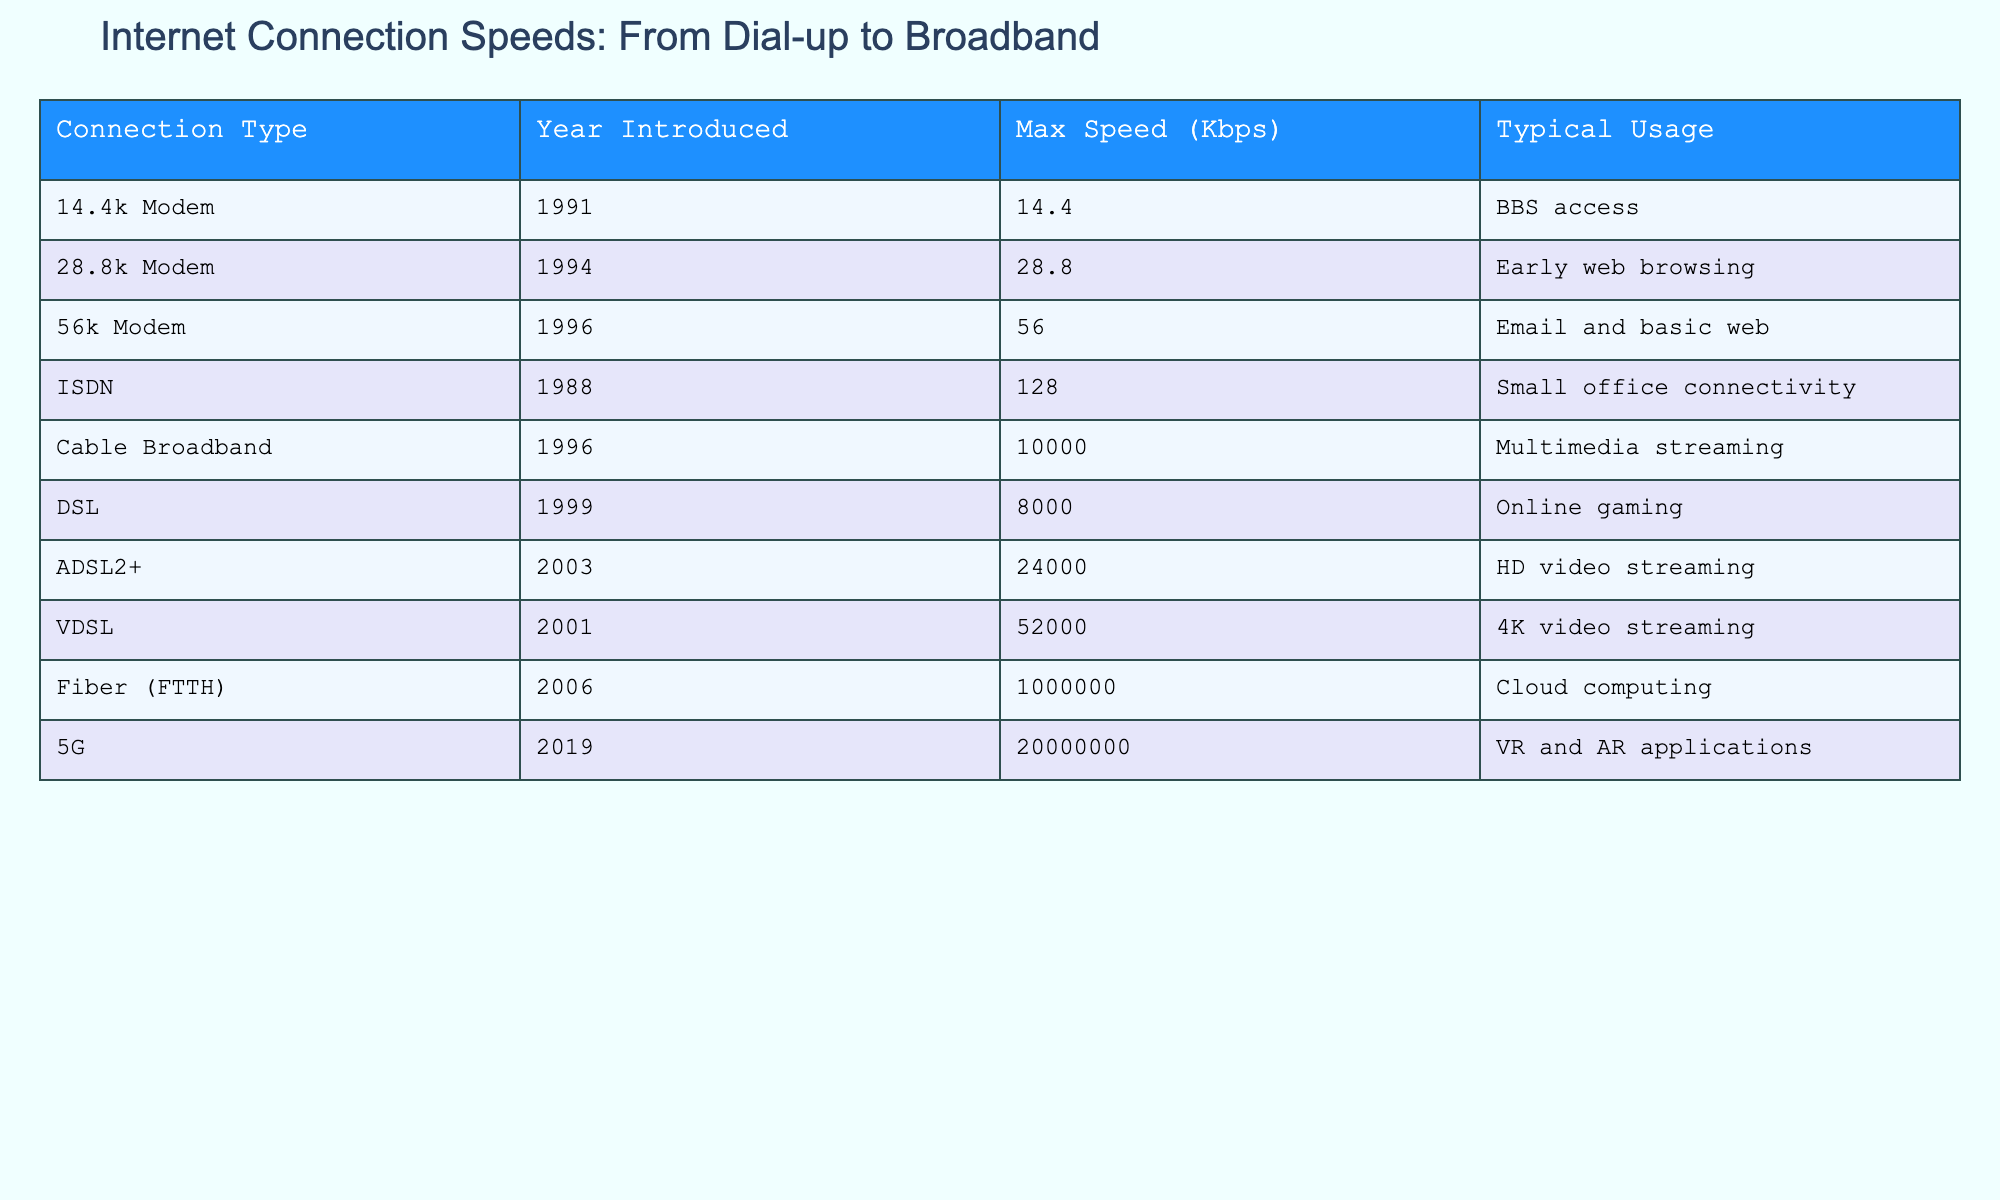What is the maximum speed of a 56k modem? The table shows that the maximum speed for a 56k modem is listed as 56 Kbps. This information can be directly found in the corresponding row of the table.
Answer: 56 Kbps In which year was the first broadband connection type introduced? According to the table, cable broadband was introduced in 1996, which is the first entry under the broadband category. This can be found in the 'Year Introduced' column.
Answer: 1996 What is the typical usage for Fiber (FTTH)? The table indicates that the typical usage for Fiber (FTTH) is cloud computing. This can be seen in the respective row for Fiber (FTTH) under the 'Typical Usage' column.
Answer: Cloud computing Is the maximum speed of 5G faster than that of ADSL2+? Yes, the maximum speed of 5G is 20,000,000 Kbps, while ADSL2+ has a maximum speed of 24,000 Kbps. A simple comparison of these two values shows that 20,000,000 is significantly greater than 24,000.
Answer: Yes What is the difference in maximum speed between ISDN and 56k modem? The maximum speed for ISDN is 128 Kbps and for 56k modem is 56 Kbps. To find the difference, subtract 56 from 128, which gives 128 - 56 = 72 Kbps.
Answer: 72 Kbps What is the average maximum speed of all connection types listed before the introduction of broadband? The connection types introduced before broadband (ISDN, 14.4k Modem, 28.8k Modem, and 56k Modem) have maximum speeds of 128 Kbps, 14.4 Kbps, 28.8 Kbps, and 56 Kbps respectively. Their sum is 128 + 14.4 + 28.8 + 56 = 227.2 Kbps, and there are four connection types, so the average is 227.2 / 4 = 56.8 Kbps.
Answer: 56.8 Kbps How many connection types have a maximum speed of over 10,000 Kbps? From the table, the connection types with speeds over 10,000 Kbps are Cable Broadband, ADSL2+, VDSL, Fiber (FTTH), and 5G. Counting these gives a total of 5 connection types.
Answer: 5 Which connection type has the highest maximum speed? The highest maximum speed in the table is for Fiber (FTTH) with a speed of 1,000,000 Kbps. This is determined by comparing the maximum speeds of all connection types listed.
Answer: Fiber (FTTH) True or False: DSL was introduced before the first 56k modem. The table shows that DSL was introduced in 1999 and the first 56k modem was introduced in 1996. Therefore, 56k modem was introduced first, making this statement false.
Answer: False 